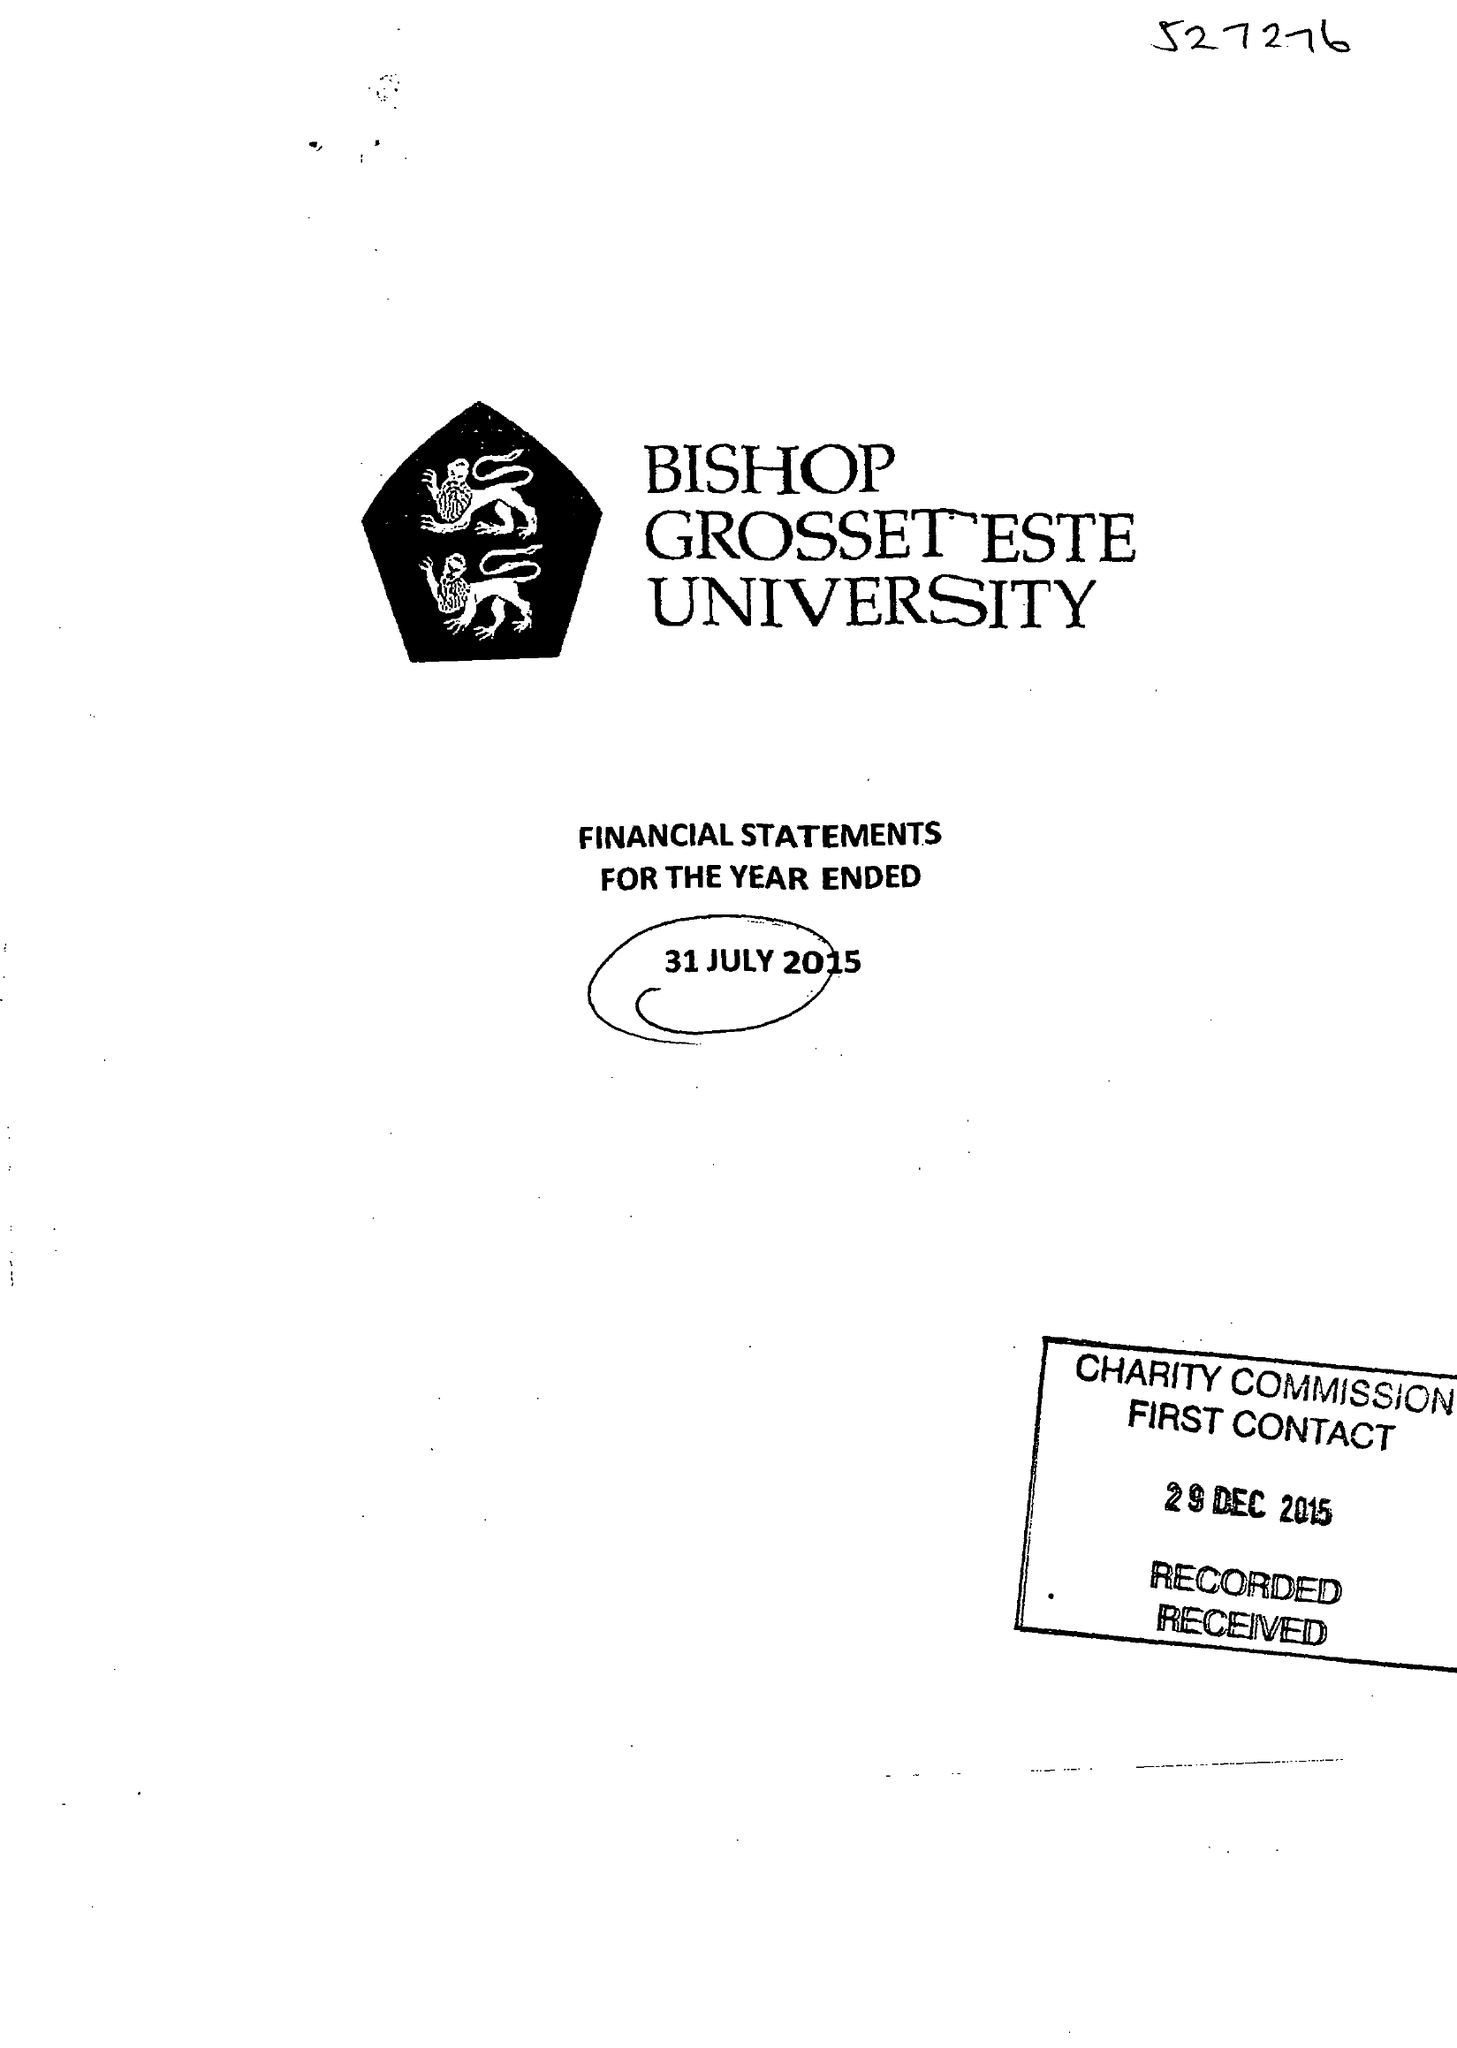What is the value for the charity_name?
Answer the question using a single word or phrase. Bishop Grosseteste University 